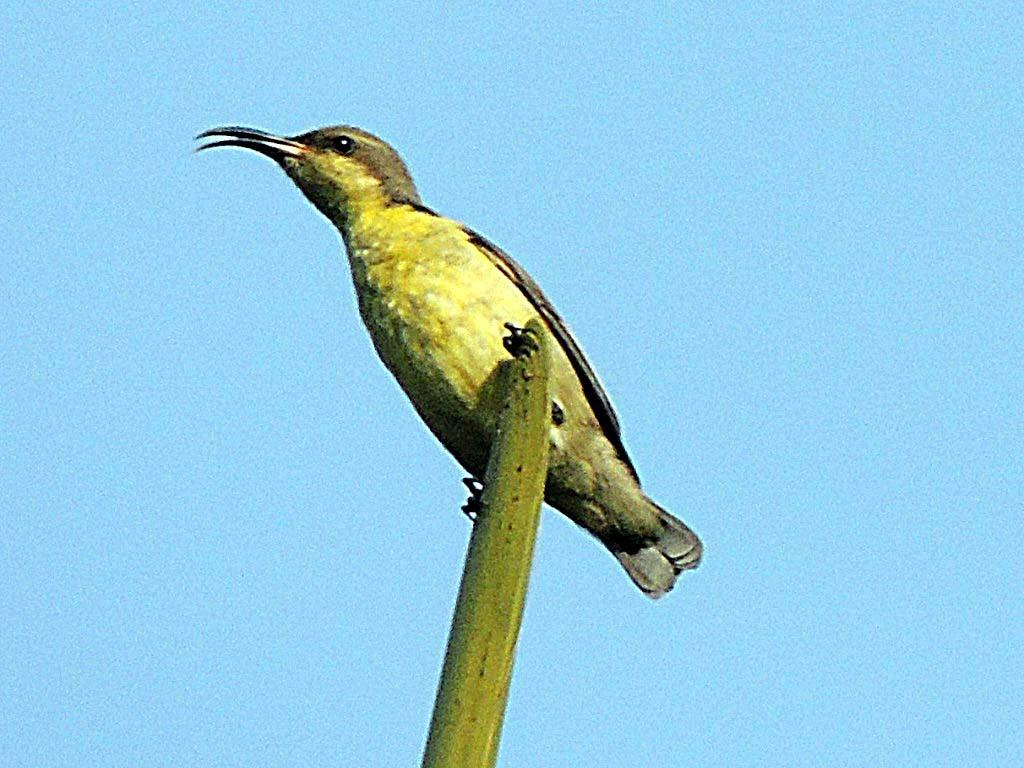What type of animal is in the image? There is a bird in the image. Where is the bird located in relation to the stem? The bird is on a stem. How are the bird and stem positioned in the image? The bird and stem are in the center of the image. What type of lock is holding the bird and stem together in the image? There is no lock present in the image; the bird is simply perched on the stem. 